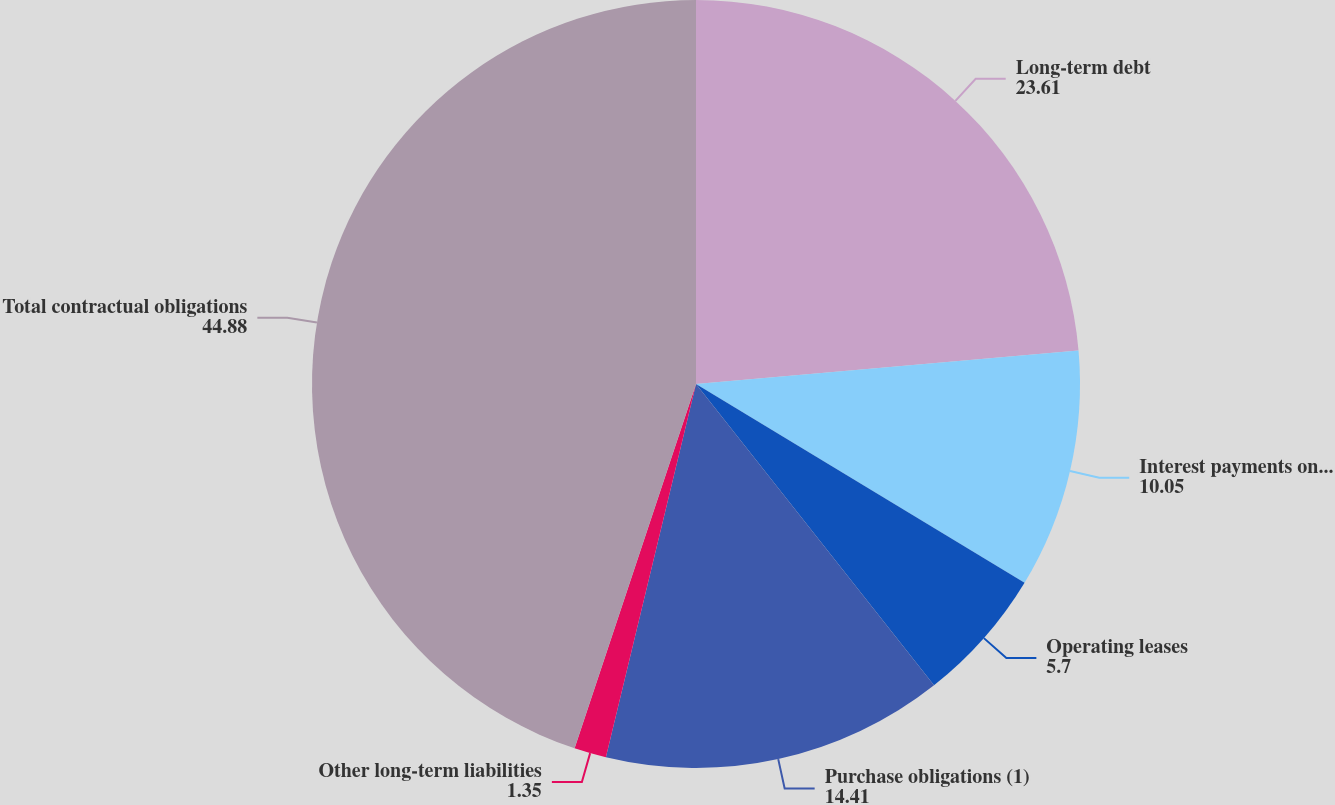Convert chart to OTSL. <chart><loc_0><loc_0><loc_500><loc_500><pie_chart><fcel>Long-term debt<fcel>Interest payments on long-term<fcel>Operating leases<fcel>Purchase obligations (1)<fcel>Other long-term liabilities<fcel>Total contractual obligations<nl><fcel>23.61%<fcel>10.05%<fcel>5.7%<fcel>14.41%<fcel>1.35%<fcel>44.88%<nl></chart> 